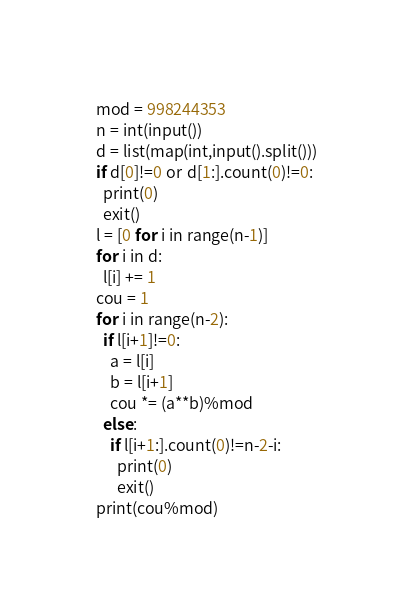Convert code to text. <code><loc_0><loc_0><loc_500><loc_500><_Python_>mod = 998244353
n = int(input())
d = list(map(int,input().split()))
if d[0]!=0 or d[1:].count(0)!=0:
  print(0)
  exit()
l = [0 for i in range(n-1)]
for i in d:
  l[i] += 1
cou = 1
for i in range(n-2):
  if l[i+1]!=0:
    a = l[i]
    b = l[i+1]
    cou *= (a**b)%mod
  else:
    if l[i+1:].count(0)!=n-2-i:
      print(0)
      exit()
print(cou%mod)</code> 